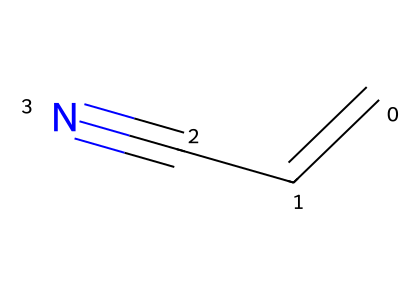how many carbon atoms are in acrylonitrile? The SMILES representation "C=CC#N" indicates that there are three carbon atoms in the structure, represented by the three 'C' characters.
Answer: 3 what functional group is present in acrylonitrile? The presence of the cyano group (-C≡N) indicates that acrylonitrile contains a nitrile functional group.
Answer: nitrile how many total atoms are in acrylonitrile? By counting the elements in the SMILES, we see there are 3 carbon (C), 3 hydrogen (H), and 1 nitrogen (N) atom, totaling 7 atoms in the molecule.
Answer: 7 what is the degree of unsaturation in acrylonitrile? The structure contains a double bond (C=C) and a triple bond (C≡N), contributing to a degree of unsaturation of 3 (1 for each double bond and 2 for the triple bond).
Answer: 3 how does the presence of the cyano group affect the chemical properties of acrylonitrile? The cyano group increases the polarity and reactivity of the molecule, leading to characteristics like enhanced solubility in polar solvents and potential for nucleophilic reactions.
Answer: increased polarity what type of hybridization is present at the carbon atoms in acrylonitrile? The terminal carbon bonded to the double bond (C=C) is sp² hybridized, while the carbon in the triple bond (C≡N) is sp hybridized. Thus, acrylonitrile exhibits both sp² and sp hybridization.
Answer: sp² and sp is acrylonitrile a saturated or unsaturated compound? Acrylonitrile contains both a double bond and a triple bond, which classify it as an unsaturated compound.
Answer: unsaturated 